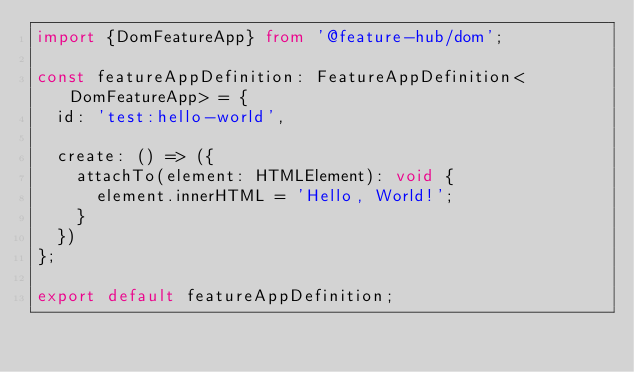<code> <loc_0><loc_0><loc_500><loc_500><_TypeScript_>import {DomFeatureApp} from '@feature-hub/dom';

const featureAppDefinition: FeatureAppDefinition<DomFeatureApp> = {
  id: 'test:hello-world',

  create: () => ({
    attachTo(element: HTMLElement): void {
      element.innerHTML = 'Hello, World!';
    }
  })
};

export default featureAppDefinition;
</code> 